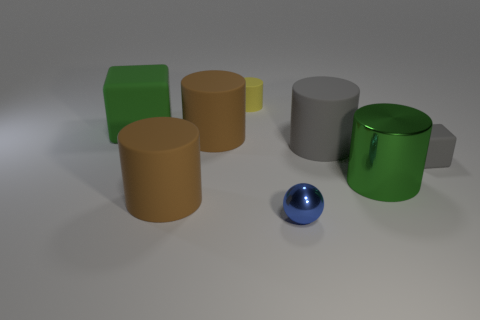Subtract all brown cylinders. How many cylinders are left? 3 Add 2 blue spheres. How many objects exist? 10 Subtract all green blocks. How many brown cylinders are left? 2 Subtract all green cylinders. How many cylinders are left? 4 Subtract all cylinders. How many objects are left? 3 Subtract 2 cylinders. How many cylinders are left? 3 Subtract all brown cylinders. Subtract all red spheres. How many cylinders are left? 3 Subtract all blue balls. Subtract all balls. How many objects are left? 6 Add 2 yellow cylinders. How many yellow cylinders are left? 3 Add 5 large brown objects. How many large brown objects exist? 7 